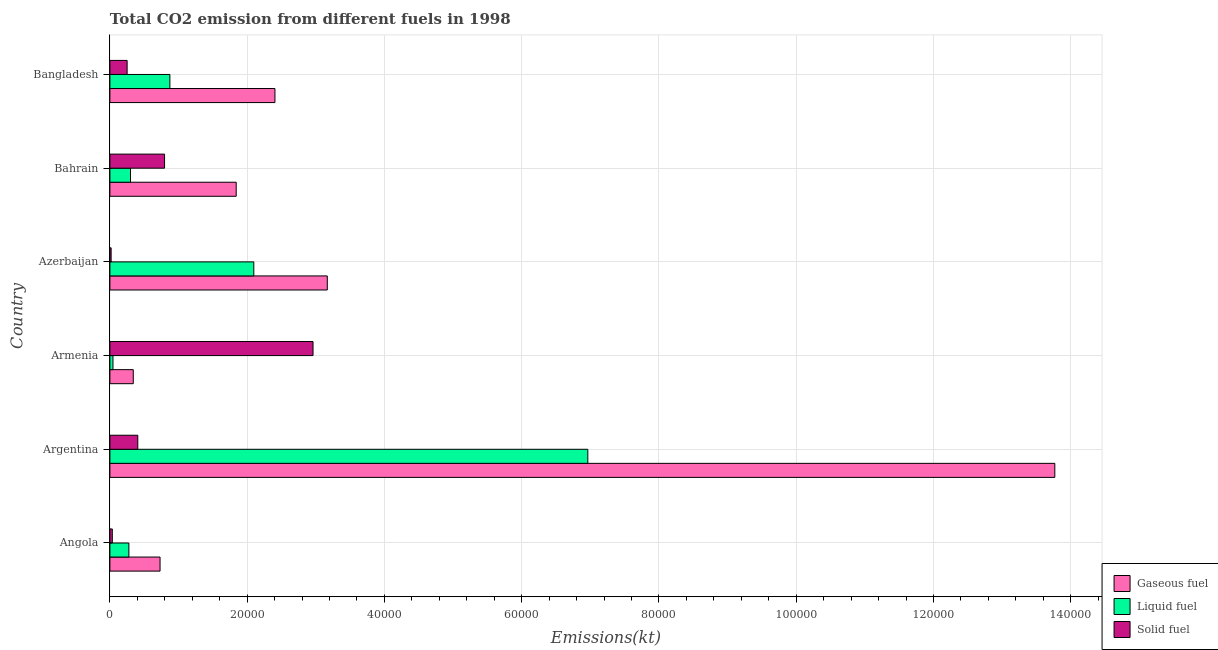How many different coloured bars are there?
Your response must be concise. 3. How many groups of bars are there?
Your response must be concise. 6. What is the amount of co2 emissions from gaseous fuel in Azerbaijan?
Provide a short and direct response. 3.17e+04. Across all countries, what is the maximum amount of co2 emissions from solid fuel?
Give a very brief answer. 2.96e+04. Across all countries, what is the minimum amount of co2 emissions from gaseous fuel?
Make the answer very short. 3406.64. In which country was the amount of co2 emissions from liquid fuel minimum?
Provide a succinct answer. Armenia. What is the total amount of co2 emissions from liquid fuel in the graph?
Offer a terse response. 1.06e+05. What is the difference between the amount of co2 emissions from liquid fuel in Armenia and that in Bangladesh?
Your response must be concise. -8291.09. What is the difference between the amount of co2 emissions from liquid fuel in Argentina and the amount of co2 emissions from gaseous fuel in Armenia?
Provide a short and direct response. 6.62e+04. What is the average amount of co2 emissions from liquid fuel per country?
Provide a succinct answer. 1.76e+04. What is the difference between the amount of co2 emissions from liquid fuel and amount of co2 emissions from solid fuel in Bahrain?
Offer a very short reply. -4961.45. In how many countries, is the amount of co2 emissions from gaseous fuel greater than 32000 kt?
Give a very brief answer. 1. What is the ratio of the amount of co2 emissions from gaseous fuel in Argentina to that in Bangladesh?
Provide a succinct answer. 5.72. What is the difference between the highest and the second highest amount of co2 emissions from liquid fuel?
Your response must be concise. 4.87e+04. What is the difference between the highest and the lowest amount of co2 emissions from liquid fuel?
Offer a terse response. 6.92e+04. Is the sum of the amount of co2 emissions from gaseous fuel in Armenia and Bangladesh greater than the maximum amount of co2 emissions from liquid fuel across all countries?
Offer a terse response. No. What does the 3rd bar from the top in Argentina represents?
Offer a very short reply. Gaseous fuel. What does the 3rd bar from the bottom in Angola represents?
Offer a terse response. Solid fuel. How many bars are there?
Make the answer very short. 18. Does the graph contain grids?
Your answer should be very brief. Yes. How many legend labels are there?
Make the answer very short. 3. What is the title of the graph?
Keep it short and to the point. Total CO2 emission from different fuels in 1998. Does "Food" appear as one of the legend labels in the graph?
Offer a terse response. No. What is the label or title of the X-axis?
Provide a short and direct response. Emissions(kt). What is the label or title of the Y-axis?
Keep it short and to the point. Country. What is the Emissions(kt) of Gaseous fuel in Angola?
Offer a terse response. 7308.33. What is the Emissions(kt) of Liquid fuel in Angola?
Ensure brevity in your answer.  2764.92. What is the Emissions(kt) in Solid fuel in Angola?
Offer a very short reply. 352.03. What is the Emissions(kt) in Gaseous fuel in Argentina?
Offer a very short reply. 1.38e+05. What is the Emissions(kt) of Liquid fuel in Argentina?
Offer a very short reply. 6.96e+04. What is the Emissions(kt) in Solid fuel in Argentina?
Provide a short and direct response. 4063.04. What is the Emissions(kt) in Gaseous fuel in Armenia?
Give a very brief answer. 3406.64. What is the Emissions(kt) of Liquid fuel in Armenia?
Your answer should be very brief. 447.37. What is the Emissions(kt) in Solid fuel in Armenia?
Provide a short and direct response. 2.96e+04. What is the Emissions(kt) in Gaseous fuel in Azerbaijan?
Keep it short and to the point. 3.17e+04. What is the Emissions(kt) of Liquid fuel in Azerbaijan?
Your response must be concise. 2.10e+04. What is the Emissions(kt) of Solid fuel in Azerbaijan?
Ensure brevity in your answer.  179.68. What is the Emissions(kt) of Gaseous fuel in Bahrain?
Offer a very short reply. 1.84e+04. What is the Emissions(kt) in Liquid fuel in Bahrain?
Make the answer very short. 3003.27. What is the Emissions(kt) in Solid fuel in Bahrain?
Provide a succinct answer. 7964.72. What is the Emissions(kt) in Gaseous fuel in Bangladesh?
Offer a terse response. 2.40e+04. What is the Emissions(kt) of Liquid fuel in Bangladesh?
Keep it short and to the point. 8738.46. What is the Emissions(kt) in Solid fuel in Bangladesh?
Ensure brevity in your answer.  2511.89. Across all countries, what is the maximum Emissions(kt) of Gaseous fuel?
Your answer should be compact. 1.38e+05. Across all countries, what is the maximum Emissions(kt) in Liquid fuel?
Offer a very short reply. 6.96e+04. Across all countries, what is the maximum Emissions(kt) of Solid fuel?
Make the answer very short. 2.96e+04. Across all countries, what is the minimum Emissions(kt) of Gaseous fuel?
Keep it short and to the point. 3406.64. Across all countries, what is the minimum Emissions(kt) of Liquid fuel?
Give a very brief answer. 447.37. Across all countries, what is the minimum Emissions(kt) in Solid fuel?
Make the answer very short. 179.68. What is the total Emissions(kt) of Gaseous fuel in the graph?
Offer a very short reply. 2.23e+05. What is the total Emissions(kt) in Liquid fuel in the graph?
Make the answer very short. 1.06e+05. What is the total Emissions(kt) in Solid fuel in the graph?
Provide a short and direct response. 4.47e+04. What is the difference between the Emissions(kt) in Gaseous fuel in Angola and that in Argentina?
Offer a very short reply. -1.30e+05. What is the difference between the Emissions(kt) of Liquid fuel in Angola and that in Argentina?
Offer a very short reply. -6.69e+04. What is the difference between the Emissions(kt) in Solid fuel in Angola and that in Argentina?
Provide a short and direct response. -3711. What is the difference between the Emissions(kt) of Gaseous fuel in Angola and that in Armenia?
Your answer should be compact. 3901.69. What is the difference between the Emissions(kt) of Liquid fuel in Angola and that in Armenia?
Your response must be concise. 2317.54. What is the difference between the Emissions(kt) of Solid fuel in Angola and that in Armenia?
Your answer should be compact. -2.92e+04. What is the difference between the Emissions(kt) in Gaseous fuel in Angola and that in Azerbaijan?
Your response must be concise. -2.44e+04. What is the difference between the Emissions(kt) in Liquid fuel in Angola and that in Azerbaijan?
Keep it short and to the point. -1.82e+04. What is the difference between the Emissions(kt) of Solid fuel in Angola and that in Azerbaijan?
Offer a terse response. 172.35. What is the difference between the Emissions(kt) in Gaseous fuel in Angola and that in Bahrain?
Give a very brief answer. -1.11e+04. What is the difference between the Emissions(kt) in Liquid fuel in Angola and that in Bahrain?
Provide a succinct answer. -238.35. What is the difference between the Emissions(kt) in Solid fuel in Angola and that in Bahrain?
Your answer should be compact. -7612.69. What is the difference between the Emissions(kt) in Gaseous fuel in Angola and that in Bangladesh?
Provide a short and direct response. -1.67e+04. What is the difference between the Emissions(kt) of Liquid fuel in Angola and that in Bangladesh?
Make the answer very short. -5973.54. What is the difference between the Emissions(kt) of Solid fuel in Angola and that in Bangladesh?
Your answer should be very brief. -2159.86. What is the difference between the Emissions(kt) of Gaseous fuel in Argentina and that in Armenia?
Offer a terse response. 1.34e+05. What is the difference between the Emissions(kt) in Liquid fuel in Argentina and that in Armenia?
Your answer should be very brief. 6.92e+04. What is the difference between the Emissions(kt) in Solid fuel in Argentina and that in Armenia?
Your answer should be very brief. -2.55e+04. What is the difference between the Emissions(kt) in Gaseous fuel in Argentina and that in Azerbaijan?
Ensure brevity in your answer.  1.06e+05. What is the difference between the Emissions(kt) in Liquid fuel in Argentina and that in Azerbaijan?
Offer a terse response. 4.87e+04. What is the difference between the Emissions(kt) in Solid fuel in Argentina and that in Azerbaijan?
Your response must be concise. 3883.35. What is the difference between the Emissions(kt) in Gaseous fuel in Argentina and that in Bahrain?
Offer a terse response. 1.19e+05. What is the difference between the Emissions(kt) of Liquid fuel in Argentina and that in Bahrain?
Your response must be concise. 6.66e+04. What is the difference between the Emissions(kt) in Solid fuel in Argentina and that in Bahrain?
Your answer should be compact. -3901.69. What is the difference between the Emissions(kt) of Gaseous fuel in Argentina and that in Bangladesh?
Give a very brief answer. 1.14e+05. What is the difference between the Emissions(kt) of Liquid fuel in Argentina and that in Bangladesh?
Ensure brevity in your answer.  6.09e+04. What is the difference between the Emissions(kt) in Solid fuel in Argentina and that in Bangladesh?
Your answer should be very brief. 1551.14. What is the difference between the Emissions(kt) of Gaseous fuel in Armenia and that in Azerbaijan?
Give a very brief answer. -2.83e+04. What is the difference between the Emissions(kt) in Liquid fuel in Armenia and that in Azerbaijan?
Make the answer very short. -2.05e+04. What is the difference between the Emissions(kt) of Solid fuel in Armenia and that in Azerbaijan?
Give a very brief answer. 2.94e+04. What is the difference between the Emissions(kt) in Gaseous fuel in Armenia and that in Bahrain?
Offer a very short reply. -1.50e+04. What is the difference between the Emissions(kt) of Liquid fuel in Armenia and that in Bahrain?
Your answer should be compact. -2555.9. What is the difference between the Emissions(kt) of Solid fuel in Armenia and that in Bahrain?
Offer a terse response. 2.16e+04. What is the difference between the Emissions(kt) of Gaseous fuel in Armenia and that in Bangladesh?
Offer a terse response. -2.06e+04. What is the difference between the Emissions(kt) of Liquid fuel in Armenia and that in Bangladesh?
Your answer should be very brief. -8291.09. What is the difference between the Emissions(kt) in Solid fuel in Armenia and that in Bangladesh?
Provide a succinct answer. 2.71e+04. What is the difference between the Emissions(kt) of Gaseous fuel in Azerbaijan and that in Bahrain?
Your response must be concise. 1.33e+04. What is the difference between the Emissions(kt) of Liquid fuel in Azerbaijan and that in Bahrain?
Ensure brevity in your answer.  1.80e+04. What is the difference between the Emissions(kt) of Solid fuel in Azerbaijan and that in Bahrain?
Ensure brevity in your answer.  -7785.04. What is the difference between the Emissions(kt) of Gaseous fuel in Azerbaijan and that in Bangladesh?
Provide a short and direct response. 7627.36. What is the difference between the Emissions(kt) in Liquid fuel in Azerbaijan and that in Bangladesh?
Offer a terse response. 1.22e+04. What is the difference between the Emissions(kt) of Solid fuel in Azerbaijan and that in Bangladesh?
Provide a succinct answer. -2332.21. What is the difference between the Emissions(kt) of Gaseous fuel in Bahrain and that in Bangladesh?
Provide a short and direct response. -5643.51. What is the difference between the Emissions(kt) in Liquid fuel in Bahrain and that in Bangladesh?
Give a very brief answer. -5735.19. What is the difference between the Emissions(kt) of Solid fuel in Bahrain and that in Bangladesh?
Provide a succinct answer. 5452.83. What is the difference between the Emissions(kt) in Gaseous fuel in Angola and the Emissions(kt) in Liquid fuel in Argentina?
Make the answer very short. -6.23e+04. What is the difference between the Emissions(kt) in Gaseous fuel in Angola and the Emissions(kt) in Solid fuel in Argentina?
Your response must be concise. 3245.3. What is the difference between the Emissions(kt) of Liquid fuel in Angola and the Emissions(kt) of Solid fuel in Argentina?
Offer a very short reply. -1298.12. What is the difference between the Emissions(kt) in Gaseous fuel in Angola and the Emissions(kt) in Liquid fuel in Armenia?
Keep it short and to the point. 6860.96. What is the difference between the Emissions(kt) in Gaseous fuel in Angola and the Emissions(kt) in Solid fuel in Armenia?
Offer a very short reply. -2.23e+04. What is the difference between the Emissions(kt) in Liquid fuel in Angola and the Emissions(kt) in Solid fuel in Armenia?
Keep it short and to the point. -2.68e+04. What is the difference between the Emissions(kt) of Gaseous fuel in Angola and the Emissions(kt) of Liquid fuel in Azerbaijan?
Keep it short and to the point. -1.37e+04. What is the difference between the Emissions(kt) in Gaseous fuel in Angola and the Emissions(kt) in Solid fuel in Azerbaijan?
Provide a short and direct response. 7128.65. What is the difference between the Emissions(kt) in Liquid fuel in Angola and the Emissions(kt) in Solid fuel in Azerbaijan?
Your response must be concise. 2585.24. What is the difference between the Emissions(kt) in Gaseous fuel in Angola and the Emissions(kt) in Liquid fuel in Bahrain?
Make the answer very short. 4305.06. What is the difference between the Emissions(kt) in Gaseous fuel in Angola and the Emissions(kt) in Solid fuel in Bahrain?
Your answer should be very brief. -656.39. What is the difference between the Emissions(kt) in Liquid fuel in Angola and the Emissions(kt) in Solid fuel in Bahrain?
Ensure brevity in your answer.  -5199.81. What is the difference between the Emissions(kt) in Gaseous fuel in Angola and the Emissions(kt) in Liquid fuel in Bangladesh?
Provide a succinct answer. -1430.13. What is the difference between the Emissions(kt) of Gaseous fuel in Angola and the Emissions(kt) of Solid fuel in Bangladesh?
Your response must be concise. 4796.44. What is the difference between the Emissions(kt) of Liquid fuel in Angola and the Emissions(kt) of Solid fuel in Bangladesh?
Make the answer very short. 253.02. What is the difference between the Emissions(kt) in Gaseous fuel in Argentina and the Emissions(kt) in Liquid fuel in Armenia?
Offer a terse response. 1.37e+05. What is the difference between the Emissions(kt) in Gaseous fuel in Argentina and the Emissions(kt) in Solid fuel in Armenia?
Provide a succinct answer. 1.08e+05. What is the difference between the Emissions(kt) of Liquid fuel in Argentina and the Emissions(kt) of Solid fuel in Armenia?
Your answer should be compact. 4.00e+04. What is the difference between the Emissions(kt) in Gaseous fuel in Argentina and the Emissions(kt) in Liquid fuel in Azerbaijan?
Offer a terse response. 1.17e+05. What is the difference between the Emissions(kt) of Gaseous fuel in Argentina and the Emissions(kt) of Solid fuel in Azerbaijan?
Offer a terse response. 1.37e+05. What is the difference between the Emissions(kt) in Liquid fuel in Argentina and the Emissions(kt) in Solid fuel in Azerbaijan?
Your answer should be very brief. 6.95e+04. What is the difference between the Emissions(kt) in Gaseous fuel in Argentina and the Emissions(kt) in Liquid fuel in Bahrain?
Provide a short and direct response. 1.35e+05. What is the difference between the Emissions(kt) in Gaseous fuel in Argentina and the Emissions(kt) in Solid fuel in Bahrain?
Keep it short and to the point. 1.30e+05. What is the difference between the Emissions(kt) in Liquid fuel in Argentina and the Emissions(kt) in Solid fuel in Bahrain?
Provide a succinct answer. 6.17e+04. What is the difference between the Emissions(kt) in Gaseous fuel in Argentina and the Emissions(kt) in Liquid fuel in Bangladesh?
Provide a short and direct response. 1.29e+05. What is the difference between the Emissions(kt) of Gaseous fuel in Argentina and the Emissions(kt) of Solid fuel in Bangladesh?
Ensure brevity in your answer.  1.35e+05. What is the difference between the Emissions(kt) of Liquid fuel in Argentina and the Emissions(kt) of Solid fuel in Bangladesh?
Your answer should be compact. 6.71e+04. What is the difference between the Emissions(kt) in Gaseous fuel in Armenia and the Emissions(kt) in Liquid fuel in Azerbaijan?
Keep it short and to the point. -1.76e+04. What is the difference between the Emissions(kt) of Gaseous fuel in Armenia and the Emissions(kt) of Solid fuel in Azerbaijan?
Offer a terse response. 3226.96. What is the difference between the Emissions(kt) of Liquid fuel in Armenia and the Emissions(kt) of Solid fuel in Azerbaijan?
Keep it short and to the point. 267.69. What is the difference between the Emissions(kt) of Gaseous fuel in Armenia and the Emissions(kt) of Liquid fuel in Bahrain?
Give a very brief answer. 403.37. What is the difference between the Emissions(kt) of Gaseous fuel in Armenia and the Emissions(kt) of Solid fuel in Bahrain?
Give a very brief answer. -4558.08. What is the difference between the Emissions(kt) in Liquid fuel in Armenia and the Emissions(kt) in Solid fuel in Bahrain?
Give a very brief answer. -7517.35. What is the difference between the Emissions(kt) of Gaseous fuel in Armenia and the Emissions(kt) of Liquid fuel in Bangladesh?
Keep it short and to the point. -5331.82. What is the difference between the Emissions(kt) in Gaseous fuel in Armenia and the Emissions(kt) in Solid fuel in Bangladesh?
Your answer should be very brief. 894.75. What is the difference between the Emissions(kt) of Liquid fuel in Armenia and the Emissions(kt) of Solid fuel in Bangladesh?
Keep it short and to the point. -2064.52. What is the difference between the Emissions(kt) in Gaseous fuel in Azerbaijan and the Emissions(kt) in Liquid fuel in Bahrain?
Provide a short and direct response. 2.87e+04. What is the difference between the Emissions(kt) in Gaseous fuel in Azerbaijan and the Emissions(kt) in Solid fuel in Bahrain?
Offer a very short reply. 2.37e+04. What is the difference between the Emissions(kt) in Liquid fuel in Azerbaijan and the Emissions(kt) in Solid fuel in Bahrain?
Ensure brevity in your answer.  1.30e+04. What is the difference between the Emissions(kt) of Gaseous fuel in Azerbaijan and the Emissions(kt) of Liquid fuel in Bangladesh?
Ensure brevity in your answer.  2.29e+04. What is the difference between the Emissions(kt) in Gaseous fuel in Azerbaijan and the Emissions(kt) in Solid fuel in Bangladesh?
Provide a succinct answer. 2.92e+04. What is the difference between the Emissions(kt) of Liquid fuel in Azerbaijan and the Emissions(kt) of Solid fuel in Bangladesh?
Ensure brevity in your answer.  1.85e+04. What is the difference between the Emissions(kt) of Gaseous fuel in Bahrain and the Emissions(kt) of Liquid fuel in Bangladesh?
Offer a terse response. 9666.21. What is the difference between the Emissions(kt) in Gaseous fuel in Bahrain and the Emissions(kt) in Solid fuel in Bangladesh?
Offer a terse response. 1.59e+04. What is the difference between the Emissions(kt) in Liquid fuel in Bahrain and the Emissions(kt) in Solid fuel in Bangladesh?
Ensure brevity in your answer.  491.38. What is the average Emissions(kt) in Gaseous fuel per country?
Your response must be concise. 3.71e+04. What is the average Emissions(kt) in Liquid fuel per country?
Your answer should be compact. 1.76e+04. What is the average Emissions(kt) in Solid fuel per country?
Offer a very short reply. 7444.62. What is the difference between the Emissions(kt) in Gaseous fuel and Emissions(kt) in Liquid fuel in Angola?
Give a very brief answer. 4543.41. What is the difference between the Emissions(kt) in Gaseous fuel and Emissions(kt) in Solid fuel in Angola?
Offer a terse response. 6956.3. What is the difference between the Emissions(kt) of Liquid fuel and Emissions(kt) of Solid fuel in Angola?
Give a very brief answer. 2412.89. What is the difference between the Emissions(kt) of Gaseous fuel and Emissions(kt) of Liquid fuel in Argentina?
Make the answer very short. 6.80e+04. What is the difference between the Emissions(kt) in Gaseous fuel and Emissions(kt) in Solid fuel in Argentina?
Your response must be concise. 1.34e+05. What is the difference between the Emissions(kt) in Liquid fuel and Emissions(kt) in Solid fuel in Argentina?
Give a very brief answer. 6.56e+04. What is the difference between the Emissions(kt) in Gaseous fuel and Emissions(kt) in Liquid fuel in Armenia?
Give a very brief answer. 2959.27. What is the difference between the Emissions(kt) in Gaseous fuel and Emissions(kt) in Solid fuel in Armenia?
Provide a short and direct response. -2.62e+04. What is the difference between the Emissions(kt) in Liquid fuel and Emissions(kt) in Solid fuel in Armenia?
Your response must be concise. -2.91e+04. What is the difference between the Emissions(kt) in Gaseous fuel and Emissions(kt) in Liquid fuel in Azerbaijan?
Ensure brevity in your answer.  1.07e+04. What is the difference between the Emissions(kt) in Gaseous fuel and Emissions(kt) in Solid fuel in Azerbaijan?
Provide a succinct answer. 3.15e+04. What is the difference between the Emissions(kt) of Liquid fuel and Emissions(kt) of Solid fuel in Azerbaijan?
Keep it short and to the point. 2.08e+04. What is the difference between the Emissions(kt) of Gaseous fuel and Emissions(kt) of Liquid fuel in Bahrain?
Your response must be concise. 1.54e+04. What is the difference between the Emissions(kt) of Gaseous fuel and Emissions(kt) of Solid fuel in Bahrain?
Make the answer very short. 1.04e+04. What is the difference between the Emissions(kt) in Liquid fuel and Emissions(kt) in Solid fuel in Bahrain?
Your answer should be very brief. -4961.45. What is the difference between the Emissions(kt) of Gaseous fuel and Emissions(kt) of Liquid fuel in Bangladesh?
Offer a terse response. 1.53e+04. What is the difference between the Emissions(kt) of Gaseous fuel and Emissions(kt) of Solid fuel in Bangladesh?
Your response must be concise. 2.15e+04. What is the difference between the Emissions(kt) of Liquid fuel and Emissions(kt) of Solid fuel in Bangladesh?
Provide a succinct answer. 6226.57. What is the ratio of the Emissions(kt) in Gaseous fuel in Angola to that in Argentina?
Give a very brief answer. 0.05. What is the ratio of the Emissions(kt) in Liquid fuel in Angola to that in Argentina?
Give a very brief answer. 0.04. What is the ratio of the Emissions(kt) in Solid fuel in Angola to that in Argentina?
Provide a short and direct response. 0.09. What is the ratio of the Emissions(kt) in Gaseous fuel in Angola to that in Armenia?
Provide a short and direct response. 2.15. What is the ratio of the Emissions(kt) of Liquid fuel in Angola to that in Armenia?
Your answer should be very brief. 6.18. What is the ratio of the Emissions(kt) of Solid fuel in Angola to that in Armenia?
Offer a terse response. 0.01. What is the ratio of the Emissions(kt) of Gaseous fuel in Angola to that in Azerbaijan?
Your answer should be compact. 0.23. What is the ratio of the Emissions(kt) of Liquid fuel in Angola to that in Azerbaijan?
Offer a terse response. 0.13. What is the ratio of the Emissions(kt) in Solid fuel in Angola to that in Azerbaijan?
Your response must be concise. 1.96. What is the ratio of the Emissions(kt) of Gaseous fuel in Angola to that in Bahrain?
Offer a very short reply. 0.4. What is the ratio of the Emissions(kt) of Liquid fuel in Angola to that in Bahrain?
Ensure brevity in your answer.  0.92. What is the ratio of the Emissions(kt) of Solid fuel in Angola to that in Bahrain?
Provide a short and direct response. 0.04. What is the ratio of the Emissions(kt) of Gaseous fuel in Angola to that in Bangladesh?
Give a very brief answer. 0.3. What is the ratio of the Emissions(kt) in Liquid fuel in Angola to that in Bangladesh?
Give a very brief answer. 0.32. What is the ratio of the Emissions(kt) of Solid fuel in Angola to that in Bangladesh?
Offer a terse response. 0.14. What is the ratio of the Emissions(kt) of Gaseous fuel in Argentina to that in Armenia?
Your response must be concise. 40.41. What is the ratio of the Emissions(kt) in Liquid fuel in Argentina to that in Armenia?
Give a very brief answer. 155.65. What is the ratio of the Emissions(kt) of Solid fuel in Argentina to that in Armenia?
Provide a short and direct response. 0.14. What is the ratio of the Emissions(kt) in Gaseous fuel in Argentina to that in Azerbaijan?
Your answer should be compact. 4.35. What is the ratio of the Emissions(kt) of Liquid fuel in Argentina to that in Azerbaijan?
Your answer should be very brief. 3.32. What is the ratio of the Emissions(kt) in Solid fuel in Argentina to that in Azerbaijan?
Offer a terse response. 22.61. What is the ratio of the Emissions(kt) of Gaseous fuel in Argentina to that in Bahrain?
Offer a terse response. 7.48. What is the ratio of the Emissions(kt) of Liquid fuel in Argentina to that in Bahrain?
Your answer should be very brief. 23.19. What is the ratio of the Emissions(kt) of Solid fuel in Argentina to that in Bahrain?
Give a very brief answer. 0.51. What is the ratio of the Emissions(kt) in Gaseous fuel in Argentina to that in Bangladesh?
Your answer should be very brief. 5.72. What is the ratio of the Emissions(kt) of Liquid fuel in Argentina to that in Bangladesh?
Keep it short and to the point. 7.97. What is the ratio of the Emissions(kt) in Solid fuel in Argentina to that in Bangladesh?
Offer a terse response. 1.62. What is the ratio of the Emissions(kt) in Gaseous fuel in Armenia to that in Azerbaijan?
Provide a succinct answer. 0.11. What is the ratio of the Emissions(kt) of Liquid fuel in Armenia to that in Azerbaijan?
Provide a succinct answer. 0.02. What is the ratio of the Emissions(kt) in Solid fuel in Armenia to that in Azerbaijan?
Your response must be concise. 164.71. What is the ratio of the Emissions(kt) of Gaseous fuel in Armenia to that in Bahrain?
Ensure brevity in your answer.  0.19. What is the ratio of the Emissions(kt) of Liquid fuel in Armenia to that in Bahrain?
Ensure brevity in your answer.  0.15. What is the ratio of the Emissions(kt) of Solid fuel in Armenia to that in Bahrain?
Your response must be concise. 3.72. What is the ratio of the Emissions(kt) of Gaseous fuel in Armenia to that in Bangladesh?
Offer a terse response. 0.14. What is the ratio of the Emissions(kt) in Liquid fuel in Armenia to that in Bangladesh?
Provide a succinct answer. 0.05. What is the ratio of the Emissions(kt) of Solid fuel in Armenia to that in Bangladesh?
Offer a terse response. 11.78. What is the ratio of the Emissions(kt) of Gaseous fuel in Azerbaijan to that in Bahrain?
Provide a succinct answer. 1.72. What is the ratio of the Emissions(kt) in Liquid fuel in Azerbaijan to that in Bahrain?
Ensure brevity in your answer.  6.98. What is the ratio of the Emissions(kt) in Solid fuel in Azerbaijan to that in Bahrain?
Your answer should be compact. 0.02. What is the ratio of the Emissions(kt) of Gaseous fuel in Azerbaijan to that in Bangladesh?
Your response must be concise. 1.32. What is the ratio of the Emissions(kt) in Liquid fuel in Azerbaijan to that in Bangladesh?
Provide a succinct answer. 2.4. What is the ratio of the Emissions(kt) in Solid fuel in Azerbaijan to that in Bangladesh?
Keep it short and to the point. 0.07. What is the ratio of the Emissions(kt) in Gaseous fuel in Bahrain to that in Bangladesh?
Offer a very short reply. 0.77. What is the ratio of the Emissions(kt) of Liquid fuel in Bahrain to that in Bangladesh?
Your response must be concise. 0.34. What is the ratio of the Emissions(kt) in Solid fuel in Bahrain to that in Bangladesh?
Make the answer very short. 3.17. What is the difference between the highest and the second highest Emissions(kt) in Gaseous fuel?
Keep it short and to the point. 1.06e+05. What is the difference between the highest and the second highest Emissions(kt) of Liquid fuel?
Make the answer very short. 4.87e+04. What is the difference between the highest and the second highest Emissions(kt) of Solid fuel?
Ensure brevity in your answer.  2.16e+04. What is the difference between the highest and the lowest Emissions(kt) of Gaseous fuel?
Make the answer very short. 1.34e+05. What is the difference between the highest and the lowest Emissions(kt) of Liquid fuel?
Provide a succinct answer. 6.92e+04. What is the difference between the highest and the lowest Emissions(kt) in Solid fuel?
Your response must be concise. 2.94e+04. 